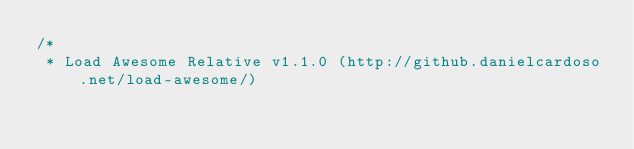<code> <loc_0><loc_0><loc_500><loc_500><_CSS_>/*
 * Load Awesome Relative v1.1.0 (http://github.danielcardoso.net/load-awesome/)</code> 